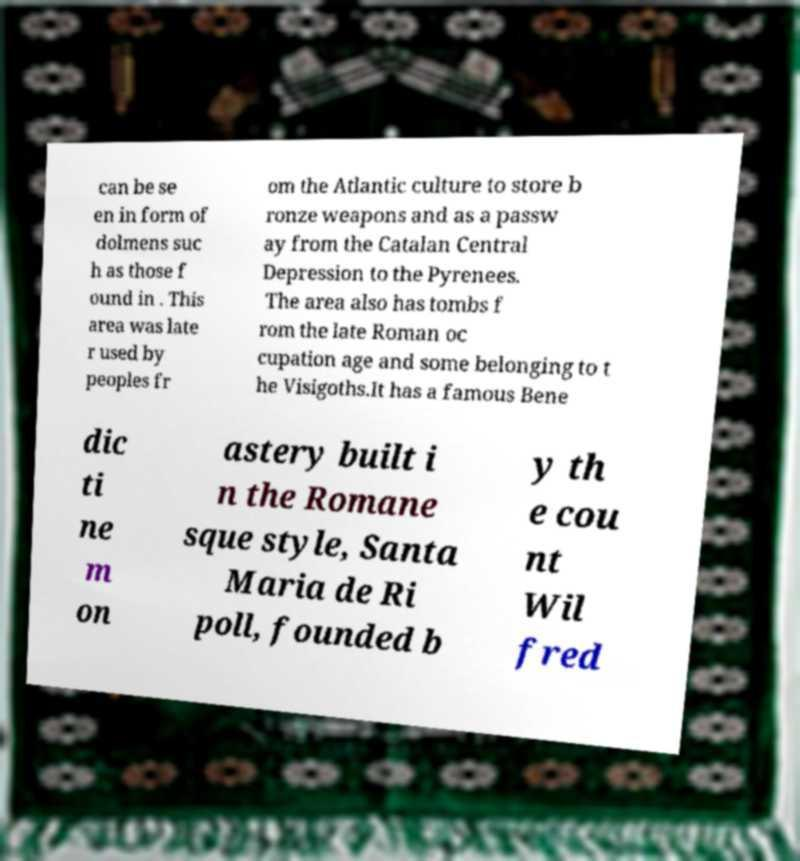There's text embedded in this image that I need extracted. Can you transcribe it verbatim? can be se en in form of dolmens suc h as those f ound in . This area was late r used by peoples fr om the Atlantic culture to store b ronze weapons and as a passw ay from the Catalan Central Depression to the Pyrenees. The area also has tombs f rom the late Roman oc cupation age and some belonging to t he Visigoths.It has a famous Bene dic ti ne m on astery built i n the Romane sque style, Santa Maria de Ri poll, founded b y th e cou nt Wil fred 